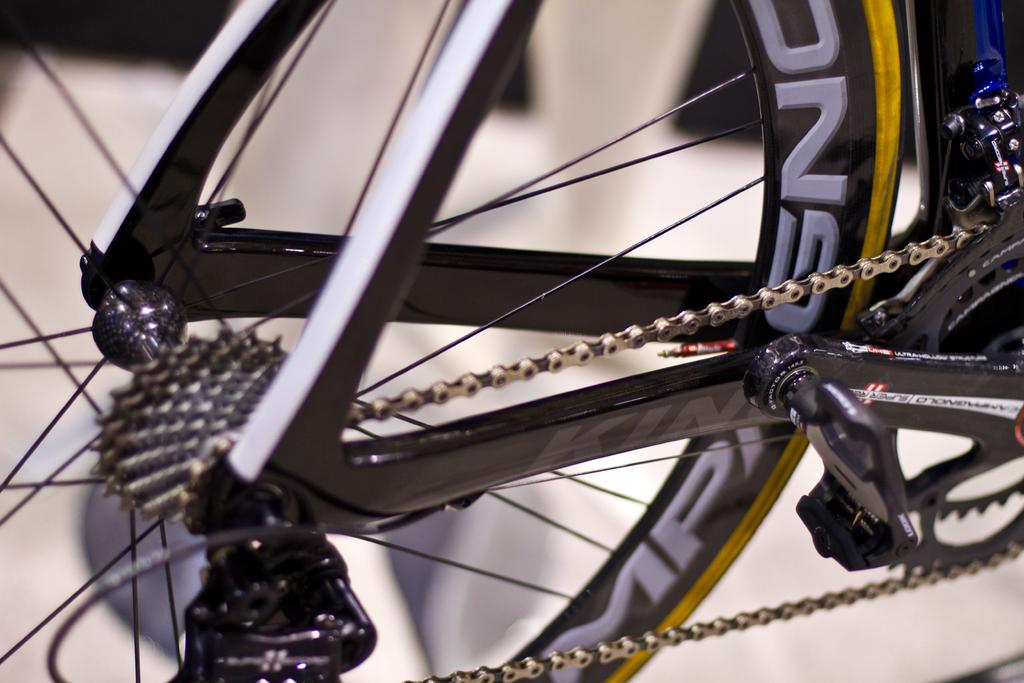What is the main object in the image? There is a chain in the image. What other component can be seen in the image? There are spokes of a wheel in the image. What might the wheel be a part of? The wheel is likely to be part of a bicycle. What type of tin can be seen hanging from the chain in the image? There is no tin present in the image. What day of the month is it according to the calendar in the image? There is no calendar present in the image. What type of advice does the dad in the image give to his child? There is no dad or child present in the image. 